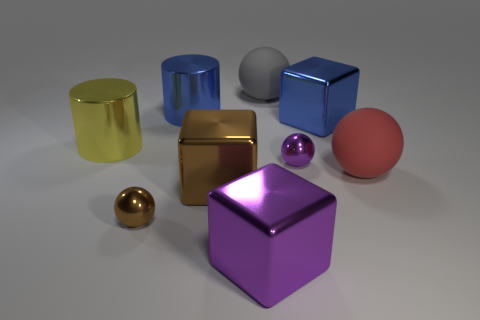Which object seems out of place compared to the others in terms of finish or texture, and why? The large grey ball in the back stands out due to its matte finish, which contrasts with the highly reflective and polished surfaces of the other objects. This could indicate it is made of a different material, such as stone or plastic. 